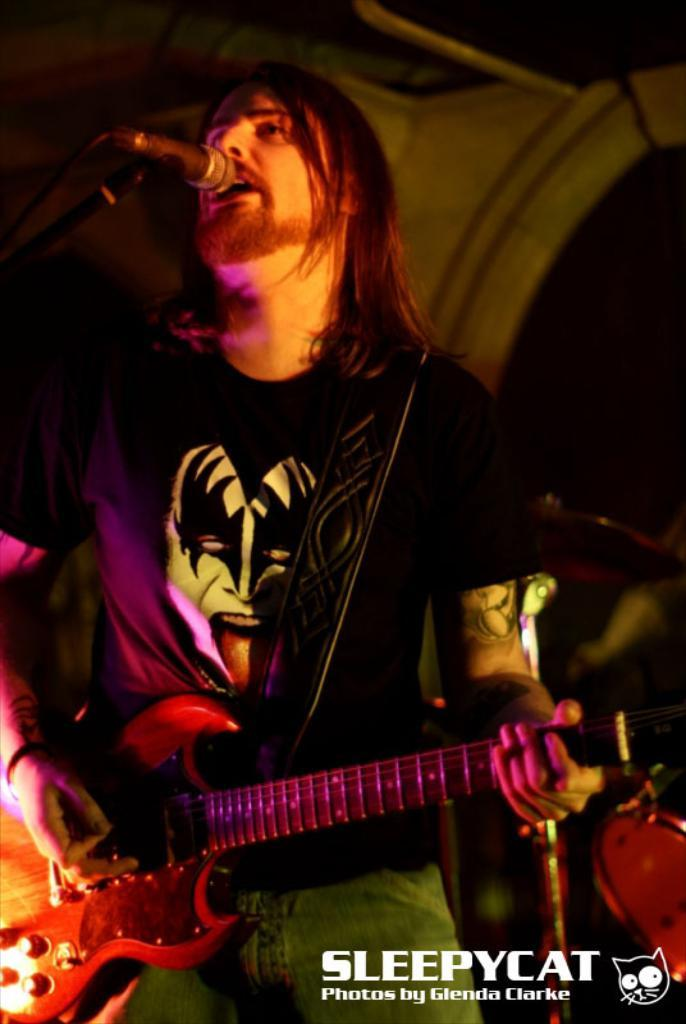What is the man in the image doing? The man is playing a guitar and singing. What object is in front of the man? There is a microphone in front of the man. What type of waste can be seen in the image? There is no waste present in the image. What is the man using to shape the wax in the image? There is no wax or any activity related to wax in the image. 